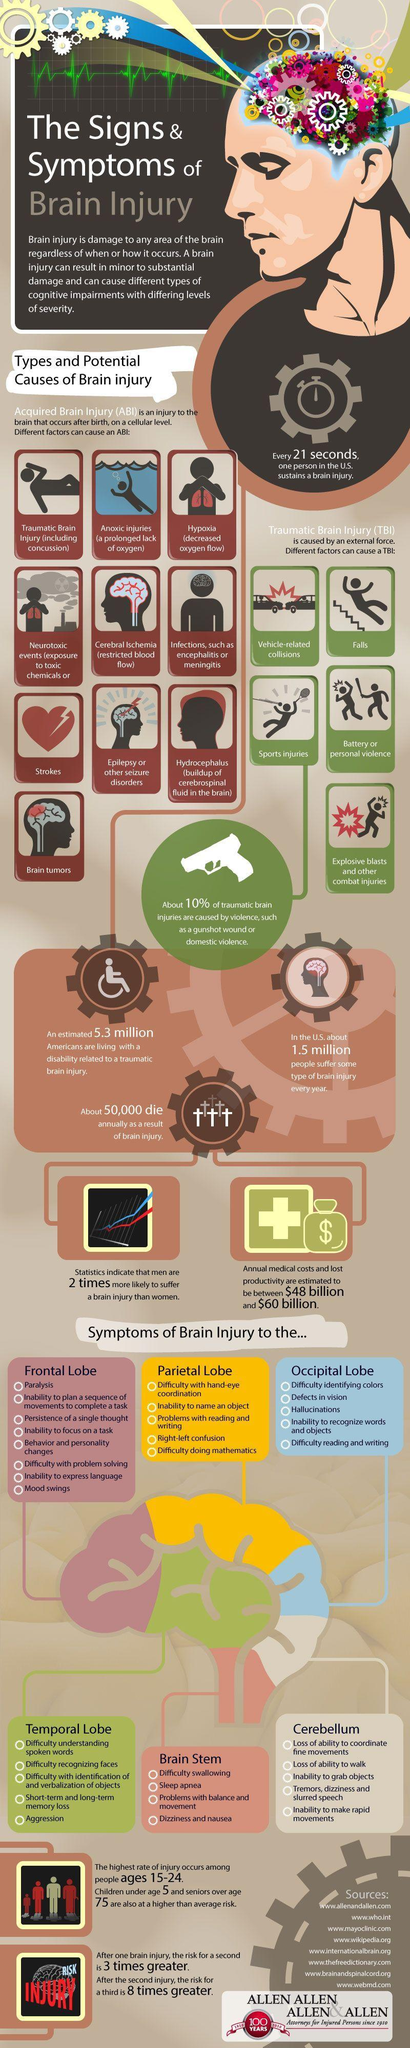Give some essential details in this illustration. Traumatic Brain Injury can be caused by six factors. The color of the temporal lobe in the infographic is green. It is estimated that approximately 5.3% of Americans are currently struggling with the effects of traumatic brain injury. Five symptoms of brain injury are listed under the category of occipital lobe. According to a study, there are approximately 10 factors that can cause Acquired Brain Injury. 